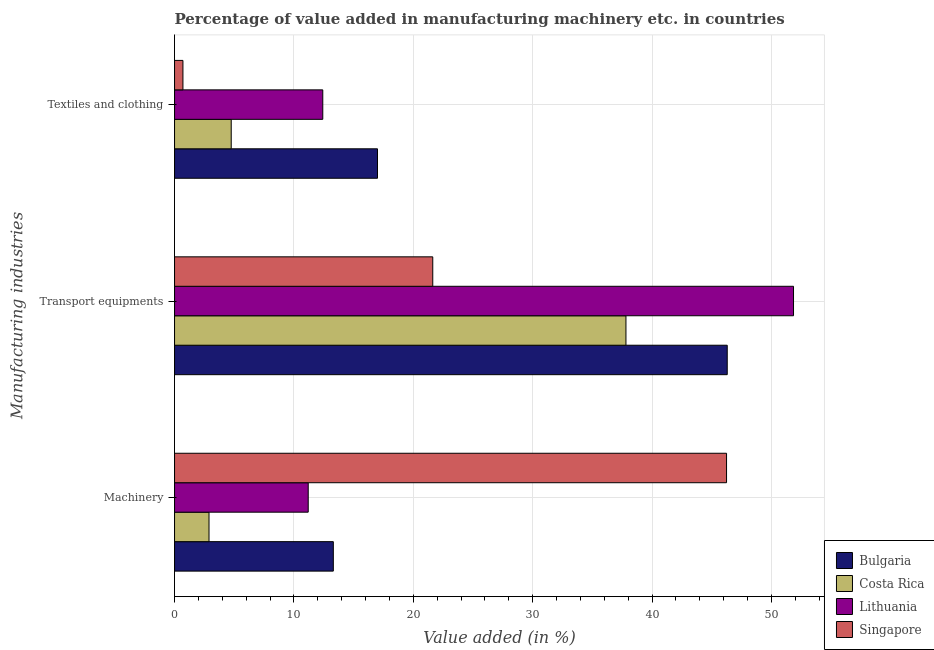How many groups of bars are there?
Make the answer very short. 3. What is the label of the 2nd group of bars from the top?
Provide a short and direct response. Transport equipments. What is the value added in manufacturing machinery in Bulgaria?
Your answer should be compact. 13.3. Across all countries, what is the maximum value added in manufacturing transport equipments?
Offer a very short reply. 51.85. Across all countries, what is the minimum value added in manufacturing transport equipments?
Your answer should be very brief. 21.63. In which country was the value added in manufacturing transport equipments maximum?
Offer a terse response. Lithuania. In which country was the value added in manufacturing textile and clothing minimum?
Your response must be concise. Singapore. What is the total value added in manufacturing textile and clothing in the graph?
Make the answer very short. 34.87. What is the difference between the value added in manufacturing textile and clothing in Bulgaria and that in Lithuania?
Offer a terse response. 4.58. What is the difference between the value added in manufacturing transport equipments in Lithuania and the value added in manufacturing textile and clothing in Singapore?
Your answer should be compact. 51.15. What is the average value added in manufacturing textile and clothing per country?
Offer a very short reply. 8.72. What is the difference between the value added in manufacturing machinery and value added in manufacturing textile and clothing in Bulgaria?
Offer a terse response. -3.7. What is the ratio of the value added in manufacturing transport equipments in Costa Rica to that in Lithuania?
Provide a short and direct response. 0.73. Is the value added in manufacturing transport equipments in Costa Rica less than that in Bulgaria?
Your answer should be very brief. Yes. Is the difference between the value added in manufacturing textile and clothing in Bulgaria and Lithuania greater than the difference between the value added in manufacturing machinery in Bulgaria and Lithuania?
Give a very brief answer. Yes. What is the difference between the highest and the second highest value added in manufacturing textile and clothing?
Ensure brevity in your answer.  4.58. What is the difference between the highest and the lowest value added in manufacturing transport equipments?
Offer a terse response. 30.22. In how many countries, is the value added in manufacturing textile and clothing greater than the average value added in manufacturing textile and clothing taken over all countries?
Make the answer very short. 2. Is the sum of the value added in manufacturing textile and clothing in Singapore and Bulgaria greater than the maximum value added in manufacturing transport equipments across all countries?
Provide a short and direct response. No. What does the 4th bar from the top in Textiles and clothing represents?
Provide a succinct answer. Bulgaria. What does the 2nd bar from the bottom in Machinery represents?
Your answer should be very brief. Costa Rica. Is it the case that in every country, the sum of the value added in manufacturing machinery and value added in manufacturing transport equipments is greater than the value added in manufacturing textile and clothing?
Make the answer very short. Yes. How many bars are there?
Give a very brief answer. 12. How many countries are there in the graph?
Give a very brief answer. 4. What is the difference between two consecutive major ticks on the X-axis?
Your answer should be very brief. 10. Does the graph contain grids?
Your response must be concise. Yes. How many legend labels are there?
Your answer should be very brief. 4. How are the legend labels stacked?
Give a very brief answer. Vertical. What is the title of the graph?
Your response must be concise. Percentage of value added in manufacturing machinery etc. in countries. Does "Egypt, Arab Rep." appear as one of the legend labels in the graph?
Provide a succinct answer. No. What is the label or title of the X-axis?
Offer a terse response. Value added (in %). What is the label or title of the Y-axis?
Your response must be concise. Manufacturing industries. What is the Value added (in %) of Bulgaria in Machinery?
Offer a very short reply. 13.3. What is the Value added (in %) of Costa Rica in Machinery?
Your answer should be very brief. 2.89. What is the Value added (in %) in Lithuania in Machinery?
Offer a very short reply. 11.2. What is the Value added (in %) of Singapore in Machinery?
Keep it short and to the point. 46.24. What is the Value added (in %) in Bulgaria in Transport equipments?
Your answer should be very brief. 46.3. What is the Value added (in %) of Costa Rica in Transport equipments?
Offer a very short reply. 37.82. What is the Value added (in %) in Lithuania in Transport equipments?
Your answer should be very brief. 51.85. What is the Value added (in %) in Singapore in Transport equipments?
Give a very brief answer. 21.63. What is the Value added (in %) of Bulgaria in Textiles and clothing?
Make the answer very short. 17. What is the Value added (in %) of Costa Rica in Textiles and clothing?
Ensure brevity in your answer.  4.75. What is the Value added (in %) of Lithuania in Textiles and clothing?
Your answer should be compact. 12.42. What is the Value added (in %) in Singapore in Textiles and clothing?
Your answer should be very brief. 0.7. Across all Manufacturing industries, what is the maximum Value added (in %) of Bulgaria?
Make the answer very short. 46.3. Across all Manufacturing industries, what is the maximum Value added (in %) in Costa Rica?
Your answer should be compact. 37.82. Across all Manufacturing industries, what is the maximum Value added (in %) in Lithuania?
Provide a short and direct response. 51.85. Across all Manufacturing industries, what is the maximum Value added (in %) in Singapore?
Offer a very short reply. 46.24. Across all Manufacturing industries, what is the minimum Value added (in %) of Bulgaria?
Offer a very short reply. 13.3. Across all Manufacturing industries, what is the minimum Value added (in %) of Costa Rica?
Provide a short and direct response. 2.89. Across all Manufacturing industries, what is the minimum Value added (in %) in Lithuania?
Provide a succinct answer. 11.2. Across all Manufacturing industries, what is the minimum Value added (in %) in Singapore?
Offer a very short reply. 0.7. What is the total Value added (in %) of Bulgaria in the graph?
Provide a short and direct response. 76.6. What is the total Value added (in %) in Costa Rica in the graph?
Offer a terse response. 45.45. What is the total Value added (in %) in Lithuania in the graph?
Give a very brief answer. 75.47. What is the total Value added (in %) of Singapore in the graph?
Make the answer very short. 68.58. What is the difference between the Value added (in %) of Bulgaria in Machinery and that in Transport equipments?
Make the answer very short. -33. What is the difference between the Value added (in %) in Costa Rica in Machinery and that in Transport equipments?
Give a very brief answer. -34.93. What is the difference between the Value added (in %) in Lithuania in Machinery and that in Transport equipments?
Provide a short and direct response. -40.65. What is the difference between the Value added (in %) in Singapore in Machinery and that in Transport equipments?
Offer a terse response. 24.61. What is the difference between the Value added (in %) in Bulgaria in Machinery and that in Textiles and clothing?
Ensure brevity in your answer.  -3.7. What is the difference between the Value added (in %) in Costa Rica in Machinery and that in Textiles and clothing?
Your response must be concise. -1.86. What is the difference between the Value added (in %) in Lithuania in Machinery and that in Textiles and clothing?
Your response must be concise. -1.22. What is the difference between the Value added (in %) in Singapore in Machinery and that in Textiles and clothing?
Provide a succinct answer. 45.54. What is the difference between the Value added (in %) of Bulgaria in Transport equipments and that in Textiles and clothing?
Your answer should be compact. 29.3. What is the difference between the Value added (in %) of Costa Rica in Transport equipments and that in Textiles and clothing?
Your answer should be compact. 33.07. What is the difference between the Value added (in %) in Lithuania in Transport equipments and that in Textiles and clothing?
Give a very brief answer. 39.43. What is the difference between the Value added (in %) in Singapore in Transport equipments and that in Textiles and clothing?
Your answer should be compact. 20.93. What is the difference between the Value added (in %) of Bulgaria in Machinery and the Value added (in %) of Costa Rica in Transport equipments?
Your answer should be compact. -24.51. What is the difference between the Value added (in %) of Bulgaria in Machinery and the Value added (in %) of Lithuania in Transport equipments?
Ensure brevity in your answer.  -38.55. What is the difference between the Value added (in %) of Bulgaria in Machinery and the Value added (in %) of Singapore in Transport equipments?
Your answer should be very brief. -8.33. What is the difference between the Value added (in %) of Costa Rica in Machinery and the Value added (in %) of Lithuania in Transport equipments?
Your answer should be very brief. -48.96. What is the difference between the Value added (in %) in Costa Rica in Machinery and the Value added (in %) in Singapore in Transport equipments?
Your answer should be compact. -18.74. What is the difference between the Value added (in %) in Lithuania in Machinery and the Value added (in %) in Singapore in Transport equipments?
Make the answer very short. -10.43. What is the difference between the Value added (in %) in Bulgaria in Machinery and the Value added (in %) in Costa Rica in Textiles and clothing?
Make the answer very short. 8.55. What is the difference between the Value added (in %) of Bulgaria in Machinery and the Value added (in %) of Lithuania in Textiles and clothing?
Your answer should be very brief. 0.88. What is the difference between the Value added (in %) in Bulgaria in Machinery and the Value added (in %) in Singapore in Textiles and clothing?
Provide a short and direct response. 12.6. What is the difference between the Value added (in %) of Costa Rica in Machinery and the Value added (in %) of Lithuania in Textiles and clothing?
Make the answer very short. -9.53. What is the difference between the Value added (in %) of Costa Rica in Machinery and the Value added (in %) of Singapore in Textiles and clothing?
Provide a succinct answer. 2.18. What is the difference between the Value added (in %) in Lithuania in Machinery and the Value added (in %) in Singapore in Textiles and clothing?
Offer a terse response. 10.49. What is the difference between the Value added (in %) of Bulgaria in Transport equipments and the Value added (in %) of Costa Rica in Textiles and clothing?
Offer a very short reply. 41.55. What is the difference between the Value added (in %) of Bulgaria in Transport equipments and the Value added (in %) of Lithuania in Textiles and clothing?
Provide a short and direct response. 33.88. What is the difference between the Value added (in %) in Bulgaria in Transport equipments and the Value added (in %) in Singapore in Textiles and clothing?
Your answer should be very brief. 45.6. What is the difference between the Value added (in %) in Costa Rica in Transport equipments and the Value added (in %) in Lithuania in Textiles and clothing?
Offer a terse response. 25.4. What is the difference between the Value added (in %) of Costa Rica in Transport equipments and the Value added (in %) of Singapore in Textiles and clothing?
Your answer should be very brief. 37.11. What is the difference between the Value added (in %) in Lithuania in Transport equipments and the Value added (in %) in Singapore in Textiles and clothing?
Provide a short and direct response. 51.15. What is the average Value added (in %) of Bulgaria per Manufacturing industries?
Provide a succinct answer. 25.53. What is the average Value added (in %) in Costa Rica per Manufacturing industries?
Provide a short and direct response. 15.15. What is the average Value added (in %) of Lithuania per Manufacturing industries?
Offer a terse response. 25.16. What is the average Value added (in %) in Singapore per Manufacturing industries?
Give a very brief answer. 22.86. What is the difference between the Value added (in %) in Bulgaria and Value added (in %) in Costa Rica in Machinery?
Your answer should be compact. 10.41. What is the difference between the Value added (in %) of Bulgaria and Value added (in %) of Lithuania in Machinery?
Offer a terse response. 2.1. What is the difference between the Value added (in %) of Bulgaria and Value added (in %) of Singapore in Machinery?
Keep it short and to the point. -32.94. What is the difference between the Value added (in %) in Costa Rica and Value added (in %) in Lithuania in Machinery?
Your response must be concise. -8.31. What is the difference between the Value added (in %) in Costa Rica and Value added (in %) in Singapore in Machinery?
Keep it short and to the point. -43.35. What is the difference between the Value added (in %) of Lithuania and Value added (in %) of Singapore in Machinery?
Your response must be concise. -35.04. What is the difference between the Value added (in %) of Bulgaria and Value added (in %) of Costa Rica in Transport equipments?
Your response must be concise. 8.48. What is the difference between the Value added (in %) in Bulgaria and Value added (in %) in Lithuania in Transport equipments?
Provide a short and direct response. -5.55. What is the difference between the Value added (in %) of Bulgaria and Value added (in %) of Singapore in Transport equipments?
Keep it short and to the point. 24.67. What is the difference between the Value added (in %) of Costa Rica and Value added (in %) of Lithuania in Transport equipments?
Provide a short and direct response. -14.04. What is the difference between the Value added (in %) of Costa Rica and Value added (in %) of Singapore in Transport equipments?
Make the answer very short. 16.18. What is the difference between the Value added (in %) in Lithuania and Value added (in %) in Singapore in Transport equipments?
Ensure brevity in your answer.  30.22. What is the difference between the Value added (in %) in Bulgaria and Value added (in %) in Costa Rica in Textiles and clothing?
Your answer should be very brief. 12.25. What is the difference between the Value added (in %) of Bulgaria and Value added (in %) of Lithuania in Textiles and clothing?
Give a very brief answer. 4.58. What is the difference between the Value added (in %) of Bulgaria and Value added (in %) of Singapore in Textiles and clothing?
Keep it short and to the point. 16.3. What is the difference between the Value added (in %) in Costa Rica and Value added (in %) in Lithuania in Textiles and clothing?
Your answer should be very brief. -7.67. What is the difference between the Value added (in %) in Costa Rica and Value added (in %) in Singapore in Textiles and clothing?
Your answer should be very brief. 4.04. What is the difference between the Value added (in %) in Lithuania and Value added (in %) in Singapore in Textiles and clothing?
Provide a succinct answer. 11.71. What is the ratio of the Value added (in %) in Bulgaria in Machinery to that in Transport equipments?
Give a very brief answer. 0.29. What is the ratio of the Value added (in %) in Costa Rica in Machinery to that in Transport equipments?
Your answer should be compact. 0.08. What is the ratio of the Value added (in %) in Lithuania in Machinery to that in Transport equipments?
Your answer should be compact. 0.22. What is the ratio of the Value added (in %) in Singapore in Machinery to that in Transport equipments?
Give a very brief answer. 2.14. What is the ratio of the Value added (in %) in Bulgaria in Machinery to that in Textiles and clothing?
Ensure brevity in your answer.  0.78. What is the ratio of the Value added (in %) in Costa Rica in Machinery to that in Textiles and clothing?
Ensure brevity in your answer.  0.61. What is the ratio of the Value added (in %) of Lithuania in Machinery to that in Textiles and clothing?
Give a very brief answer. 0.9. What is the ratio of the Value added (in %) of Singapore in Machinery to that in Textiles and clothing?
Offer a very short reply. 65.77. What is the ratio of the Value added (in %) of Bulgaria in Transport equipments to that in Textiles and clothing?
Your answer should be compact. 2.72. What is the ratio of the Value added (in %) in Costa Rica in Transport equipments to that in Textiles and clothing?
Your answer should be compact. 7.96. What is the ratio of the Value added (in %) of Lithuania in Transport equipments to that in Textiles and clothing?
Offer a very short reply. 4.18. What is the ratio of the Value added (in %) of Singapore in Transport equipments to that in Textiles and clothing?
Your response must be concise. 30.77. What is the difference between the highest and the second highest Value added (in %) in Bulgaria?
Provide a short and direct response. 29.3. What is the difference between the highest and the second highest Value added (in %) in Costa Rica?
Keep it short and to the point. 33.07. What is the difference between the highest and the second highest Value added (in %) of Lithuania?
Provide a succinct answer. 39.43. What is the difference between the highest and the second highest Value added (in %) in Singapore?
Give a very brief answer. 24.61. What is the difference between the highest and the lowest Value added (in %) in Bulgaria?
Your response must be concise. 33. What is the difference between the highest and the lowest Value added (in %) of Costa Rica?
Keep it short and to the point. 34.93. What is the difference between the highest and the lowest Value added (in %) of Lithuania?
Provide a short and direct response. 40.65. What is the difference between the highest and the lowest Value added (in %) of Singapore?
Make the answer very short. 45.54. 